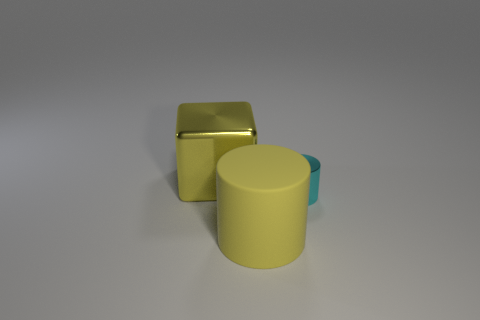What number of things are yellow things right of the big yellow metallic block or yellow metallic cubes?
Your answer should be very brief. 2. What is the material of the tiny cylinder?
Offer a terse response. Metal. Is the yellow matte object the same size as the cyan metallic thing?
Make the answer very short. No. How many cylinders are gray matte things or cyan metallic things?
Offer a very short reply. 1. There is a large thing in front of the object that is behind the small thing; what color is it?
Make the answer very short. Yellow. Are there fewer large yellow rubber things behind the tiny cyan metallic cylinder than yellow cylinders that are in front of the large yellow rubber object?
Keep it short and to the point. No. There is a yellow block; is it the same size as the yellow thing that is on the right side of the big yellow metal block?
Provide a succinct answer. Yes. What is the shape of the thing that is behind the yellow matte cylinder and on the left side of the small cyan metallic object?
Provide a succinct answer. Cube. What size is the thing that is the same material as the big cube?
Your response must be concise. Small. What number of large shiny cubes are behind the metallic object that is in front of the yellow metal object?
Ensure brevity in your answer.  1. 